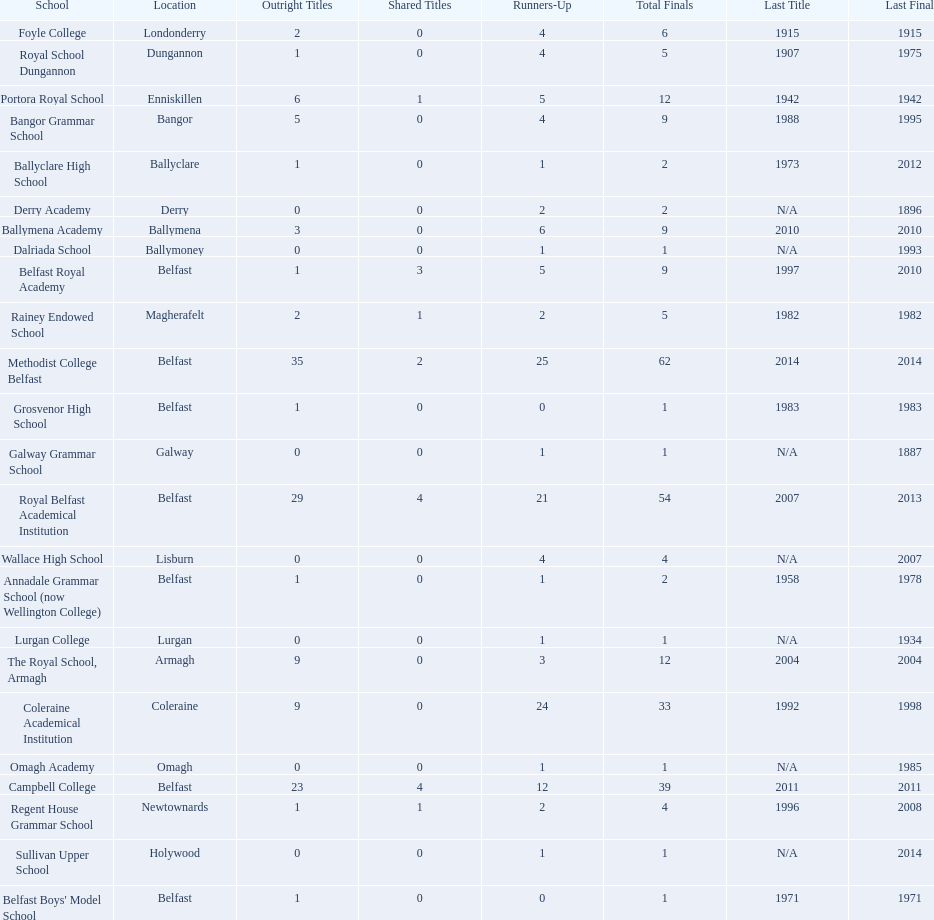Which two educational establishments each had twelve total finals? The Royal School, Armagh, Portora Royal School. 